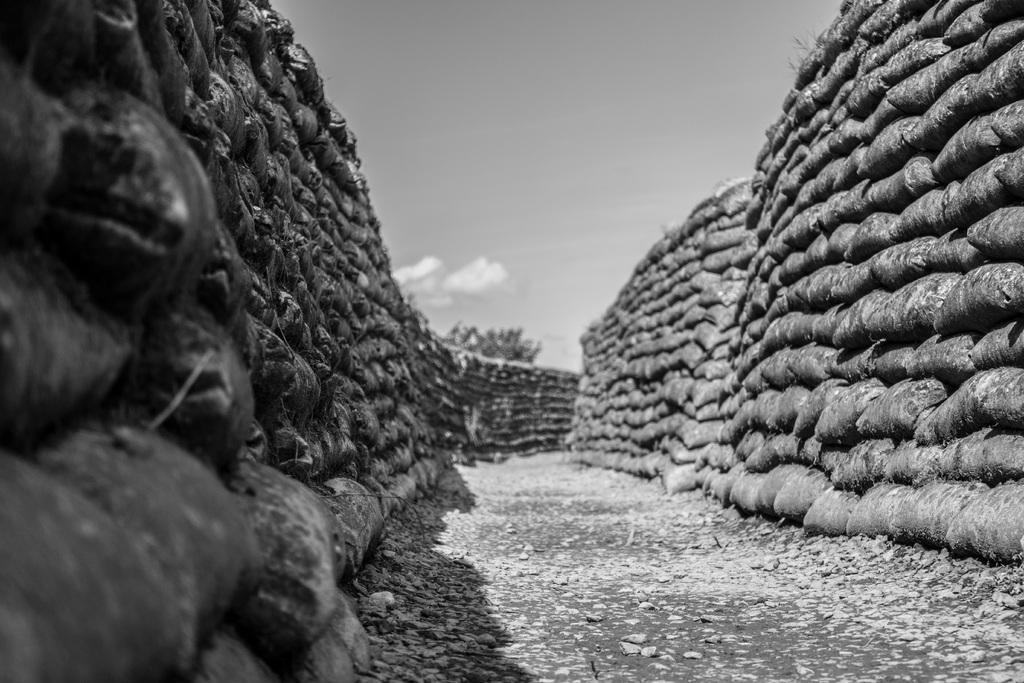In one or two sentences, can you explain what this image depicts? In this image I can see the black and white image of bags which are one on another. I can see the ground and in the background I can see the sky. 